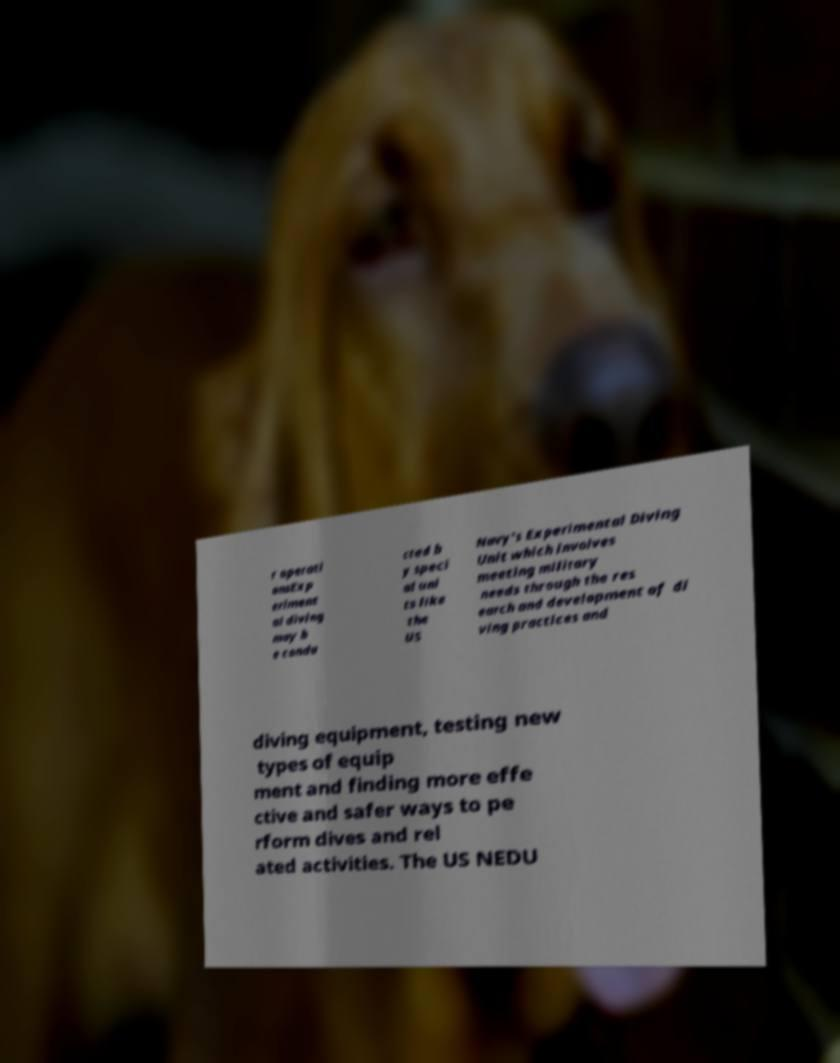For documentation purposes, I need the text within this image transcribed. Could you provide that? r operati onsExp eriment al diving may b e condu cted b y speci al uni ts like the US Navy's Experimental Diving Unit which involves meeting military needs through the res earch and development of di ving practices and diving equipment, testing new types of equip ment and finding more effe ctive and safer ways to pe rform dives and rel ated activities. The US NEDU 